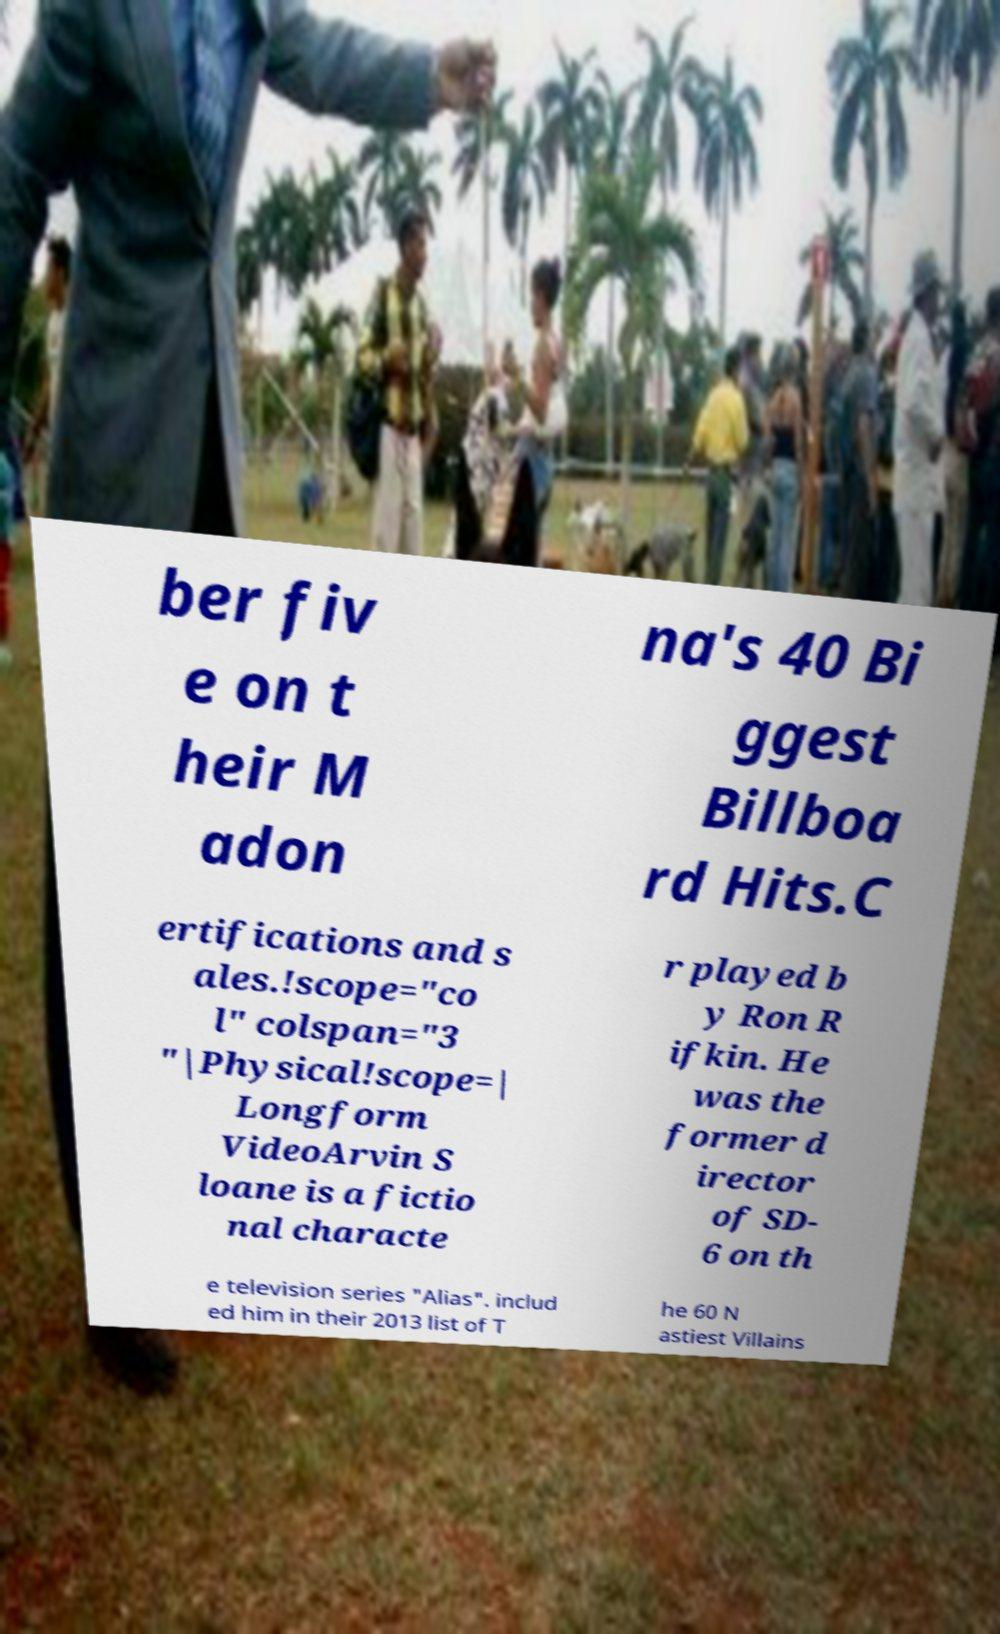Could you assist in decoding the text presented in this image and type it out clearly? ber fiv e on t heir M adon na's 40 Bi ggest Billboa rd Hits.C ertifications and s ales.!scope="co l" colspan="3 "|Physical!scope=| Longform VideoArvin S loane is a fictio nal characte r played b y Ron R ifkin. He was the former d irector of SD- 6 on th e television series "Alias". includ ed him in their 2013 list of T he 60 N astiest Villains 